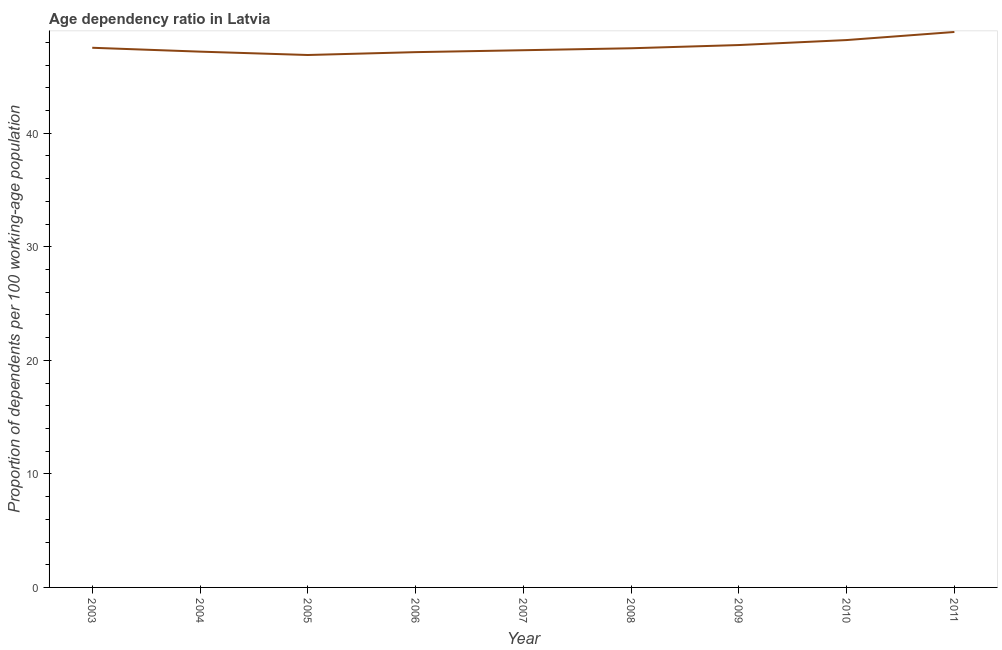What is the age dependency ratio in 2008?
Provide a succinct answer. 47.48. Across all years, what is the maximum age dependency ratio?
Your response must be concise. 48.92. Across all years, what is the minimum age dependency ratio?
Give a very brief answer. 46.89. In which year was the age dependency ratio minimum?
Your answer should be compact. 2005. What is the sum of the age dependency ratio?
Make the answer very short. 428.44. What is the difference between the age dependency ratio in 2003 and 2011?
Provide a succinct answer. -1.39. What is the average age dependency ratio per year?
Your answer should be very brief. 47.6. What is the median age dependency ratio?
Your answer should be compact. 47.48. Do a majority of the years between 2011 and 2005 (inclusive) have age dependency ratio greater than 26 ?
Give a very brief answer. Yes. What is the ratio of the age dependency ratio in 2009 to that in 2010?
Offer a very short reply. 0.99. Is the difference between the age dependency ratio in 2010 and 2011 greater than the difference between any two years?
Provide a short and direct response. No. What is the difference between the highest and the second highest age dependency ratio?
Offer a terse response. 0.71. What is the difference between the highest and the lowest age dependency ratio?
Keep it short and to the point. 2.03. How many lines are there?
Offer a very short reply. 1. What is the difference between two consecutive major ticks on the Y-axis?
Give a very brief answer. 10. Does the graph contain any zero values?
Make the answer very short. No. Does the graph contain grids?
Provide a short and direct response. No. What is the title of the graph?
Offer a very short reply. Age dependency ratio in Latvia. What is the label or title of the X-axis?
Your answer should be compact. Year. What is the label or title of the Y-axis?
Give a very brief answer. Proportion of dependents per 100 working-age population. What is the Proportion of dependents per 100 working-age population in 2003?
Your answer should be very brief. 47.53. What is the Proportion of dependents per 100 working-age population of 2004?
Provide a succinct answer. 47.19. What is the Proportion of dependents per 100 working-age population of 2005?
Your answer should be very brief. 46.89. What is the Proportion of dependents per 100 working-age population of 2006?
Give a very brief answer. 47.14. What is the Proportion of dependents per 100 working-age population in 2007?
Give a very brief answer. 47.31. What is the Proportion of dependents per 100 working-age population in 2008?
Keep it short and to the point. 47.48. What is the Proportion of dependents per 100 working-age population of 2009?
Your answer should be compact. 47.77. What is the Proportion of dependents per 100 working-age population of 2010?
Ensure brevity in your answer.  48.21. What is the Proportion of dependents per 100 working-age population of 2011?
Your answer should be very brief. 48.92. What is the difference between the Proportion of dependents per 100 working-age population in 2003 and 2004?
Ensure brevity in your answer.  0.34. What is the difference between the Proportion of dependents per 100 working-age population in 2003 and 2005?
Ensure brevity in your answer.  0.64. What is the difference between the Proportion of dependents per 100 working-age population in 2003 and 2006?
Your answer should be very brief. 0.39. What is the difference between the Proportion of dependents per 100 working-age population in 2003 and 2007?
Your response must be concise. 0.22. What is the difference between the Proportion of dependents per 100 working-age population in 2003 and 2008?
Keep it short and to the point. 0.04. What is the difference between the Proportion of dependents per 100 working-age population in 2003 and 2009?
Give a very brief answer. -0.24. What is the difference between the Proportion of dependents per 100 working-age population in 2003 and 2010?
Your answer should be very brief. -0.68. What is the difference between the Proportion of dependents per 100 working-age population in 2003 and 2011?
Provide a short and direct response. -1.39. What is the difference between the Proportion of dependents per 100 working-age population in 2004 and 2005?
Your response must be concise. 0.3. What is the difference between the Proportion of dependents per 100 working-age population in 2004 and 2006?
Keep it short and to the point. 0.04. What is the difference between the Proportion of dependents per 100 working-age population in 2004 and 2007?
Offer a terse response. -0.12. What is the difference between the Proportion of dependents per 100 working-age population in 2004 and 2008?
Offer a very short reply. -0.3. What is the difference between the Proportion of dependents per 100 working-age population in 2004 and 2009?
Give a very brief answer. -0.58. What is the difference between the Proportion of dependents per 100 working-age population in 2004 and 2010?
Provide a short and direct response. -1.02. What is the difference between the Proportion of dependents per 100 working-age population in 2004 and 2011?
Give a very brief answer. -1.73. What is the difference between the Proportion of dependents per 100 working-age population in 2005 and 2006?
Your answer should be very brief. -0.25. What is the difference between the Proportion of dependents per 100 working-age population in 2005 and 2007?
Your response must be concise. -0.42. What is the difference between the Proportion of dependents per 100 working-age population in 2005 and 2008?
Provide a short and direct response. -0.59. What is the difference between the Proportion of dependents per 100 working-age population in 2005 and 2009?
Your answer should be very brief. -0.88. What is the difference between the Proportion of dependents per 100 working-age population in 2005 and 2010?
Provide a succinct answer. -1.32. What is the difference between the Proportion of dependents per 100 working-age population in 2005 and 2011?
Your answer should be compact. -2.03. What is the difference between the Proportion of dependents per 100 working-age population in 2006 and 2007?
Provide a short and direct response. -0.17. What is the difference between the Proportion of dependents per 100 working-age population in 2006 and 2008?
Your response must be concise. -0.34. What is the difference between the Proportion of dependents per 100 working-age population in 2006 and 2009?
Offer a terse response. -0.63. What is the difference between the Proportion of dependents per 100 working-age population in 2006 and 2010?
Ensure brevity in your answer.  -1.06. What is the difference between the Proportion of dependents per 100 working-age population in 2006 and 2011?
Your answer should be compact. -1.78. What is the difference between the Proportion of dependents per 100 working-age population in 2007 and 2008?
Your answer should be compact. -0.17. What is the difference between the Proportion of dependents per 100 working-age population in 2007 and 2009?
Your answer should be compact. -0.46. What is the difference between the Proportion of dependents per 100 working-age population in 2007 and 2010?
Your response must be concise. -0.9. What is the difference between the Proportion of dependents per 100 working-age population in 2007 and 2011?
Offer a terse response. -1.61. What is the difference between the Proportion of dependents per 100 working-age population in 2008 and 2009?
Your answer should be compact. -0.28. What is the difference between the Proportion of dependents per 100 working-age population in 2008 and 2010?
Ensure brevity in your answer.  -0.72. What is the difference between the Proportion of dependents per 100 working-age population in 2008 and 2011?
Give a very brief answer. -1.43. What is the difference between the Proportion of dependents per 100 working-age population in 2009 and 2010?
Offer a very short reply. -0.44. What is the difference between the Proportion of dependents per 100 working-age population in 2009 and 2011?
Your answer should be compact. -1.15. What is the difference between the Proportion of dependents per 100 working-age population in 2010 and 2011?
Keep it short and to the point. -0.71. What is the ratio of the Proportion of dependents per 100 working-age population in 2003 to that in 2006?
Your answer should be compact. 1.01. What is the ratio of the Proportion of dependents per 100 working-age population in 2003 to that in 2010?
Keep it short and to the point. 0.99. What is the ratio of the Proportion of dependents per 100 working-age population in 2004 to that in 2005?
Offer a terse response. 1.01. What is the ratio of the Proportion of dependents per 100 working-age population in 2004 to that in 2007?
Ensure brevity in your answer.  1. What is the ratio of the Proportion of dependents per 100 working-age population in 2004 to that in 2010?
Offer a terse response. 0.98. What is the ratio of the Proportion of dependents per 100 working-age population in 2004 to that in 2011?
Make the answer very short. 0.96. What is the ratio of the Proportion of dependents per 100 working-age population in 2005 to that in 2007?
Your answer should be very brief. 0.99. What is the ratio of the Proportion of dependents per 100 working-age population in 2005 to that in 2008?
Ensure brevity in your answer.  0.99. What is the ratio of the Proportion of dependents per 100 working-age population in 2005 to that in 2011?
Keep it short and to the point. 0.96. What is the ratio of the Proportion of dependents per 100 working-age population in 2006 to that in 2009?
Provide a succinct answer. 0.99. What is the ratio of the Proportion of dependents per 100 working-age population in 2006 to that in 2010?
Provide a succinct answer. 0.98. What is the ratio of the Proportion of dependents per 100 working-age population in 2007 to that in 2010?
Offer a very short reply. 0.98. What is the ratio of the Proportion of dependents per 100 working-age population in 2008 to that in 2011?
Provide a short and direct response. 0.97. What is the ratio of the Proportion of dependents per 100 working-age population in 2010 to that in 2011?
Make the answer very short. 0.98. 